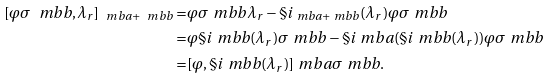<formula> <loc_0><loc_0><loc_500><loc_500>[ \varphi \sigma _ { \ } m b { b } , \lambda _ { r } ] _ { \ m b { a } + \ m b { b } } = & \varphi \sigma _ { \ } m b { b } \lambda _ { r } - \S i _ { \ m b { a } + \ m b { b } } ( \lambda _ { r } ) \varphi \sigma _ { \ } m b { b } \\ = & \varphi \S i _ { \ } m b { b } ( \lambda _ { r } ) \sigma _ { \ } m b { b } - \S i _ { \ } m b { a } ( \S i _ { \ } m b { b } ( \lambda _ { r } ) ) \varphi \sigma _ { \ } m b { b } \\ = & [ \varphi , \S i _ { \ } m b { b } ( \lambda _ { r } ) ] _ { \ } m b { a } \sigma _ { \ } m b { b } .</formula> 